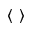Convert formula to latex. <formula><loc_0><loc_0><loc_500><loc_500>\left \langle \right \rangle</formula> 